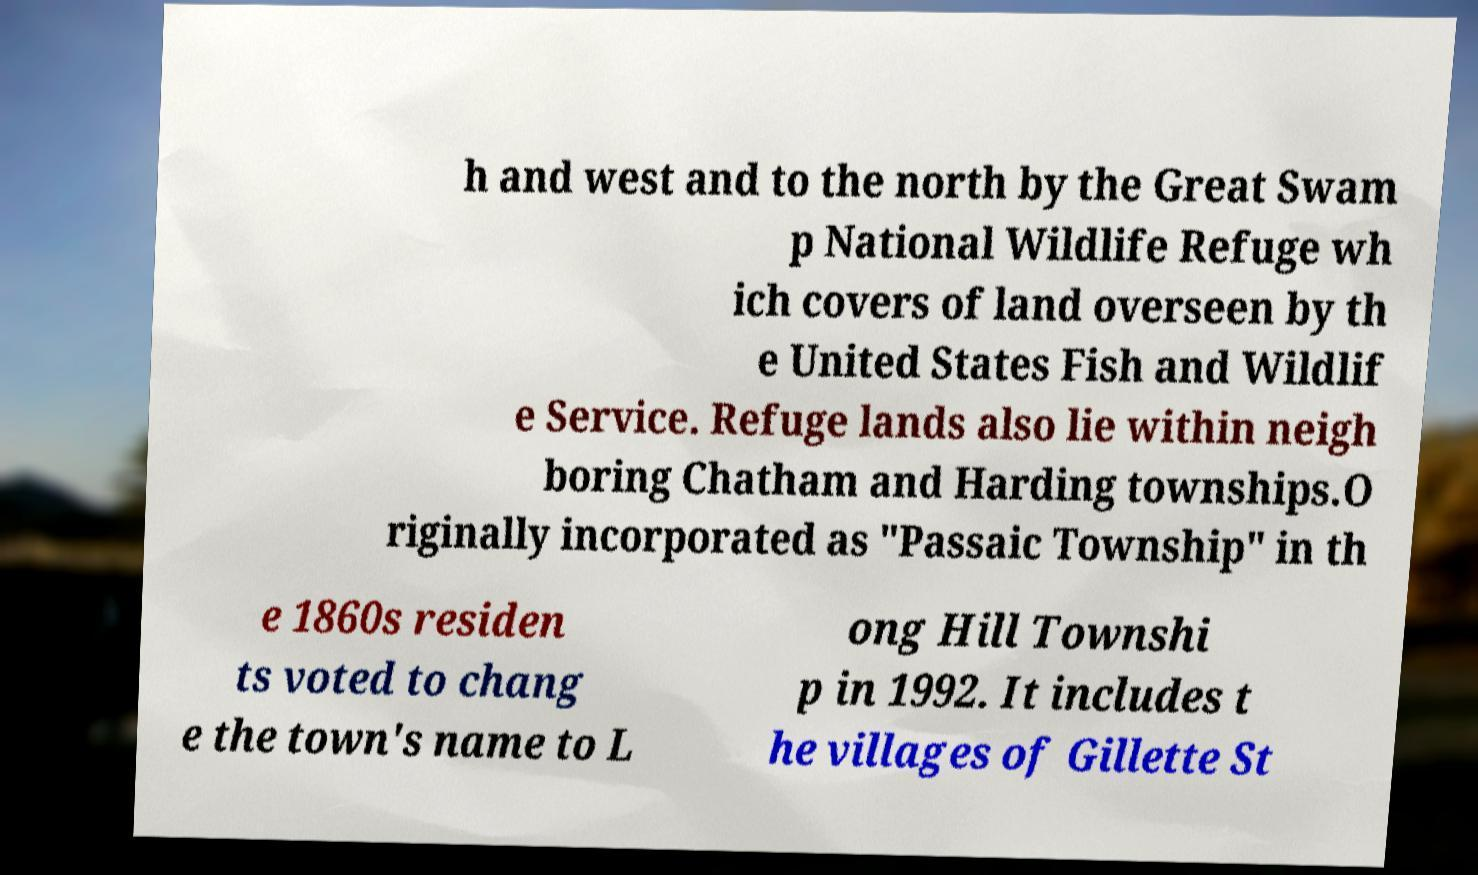What messages or text are displayed in this image? I need them in a readable, typed format. h and west and to the north by the Great Swam p National Wildlife Refuge wh ich covers of land overseen by th e United States Fish and Wildlif e Service. Refuge lands also lie within neigh boring Chatham and Harding townships.O riginally incorporated as "Passaic Township" in th e 1860s residen ts voted to chang e the town's name to L ong Hill Townshi p in 1992. It includes t he villages of Gillette St 